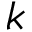Convert formula to latex. <formula><loc_0><loc_0><loc_500><loc_500>k</formula> 